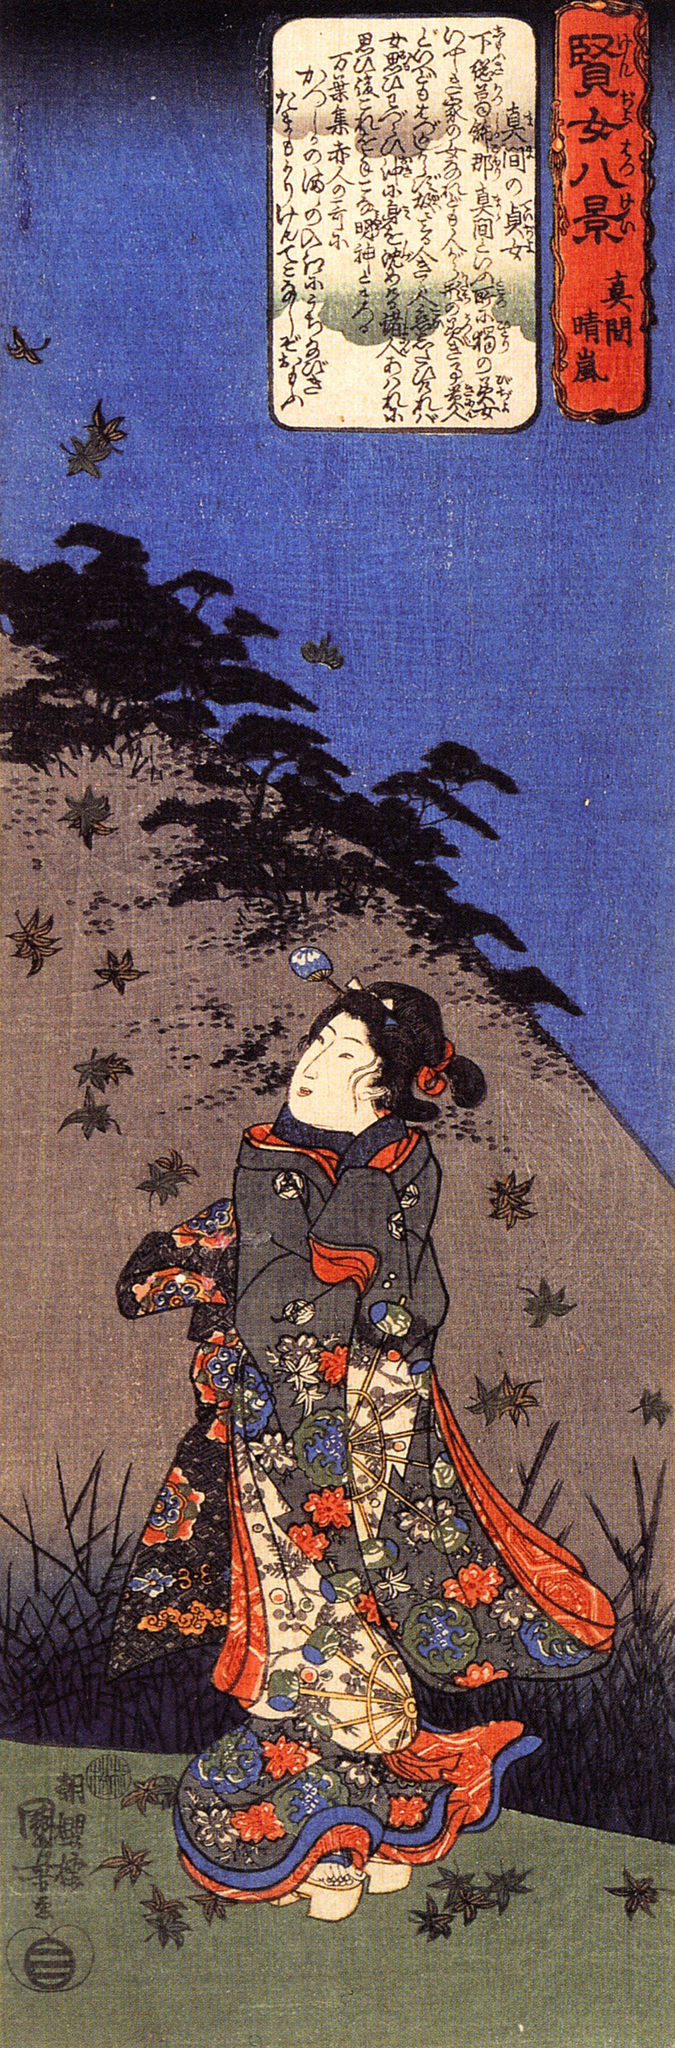Describe the historical context in which this artwork was created. This artwork is an example of ukiyo-e, a genre of Japanese woodblock prints that emerged during the Edo period (1603-1868). Ukiyo-e, which means 'pictures of the floating world,' often depicted scenes from everyday life, landscapes, and Kabuki theater actors. The Edo period was marked by a prolonged era of peace, economic growth, and flourishing arts and culture under the Tokugawa shogunate. Artists in this period often celebrated the transient beauty of life and day-to-day activities, which is evident in the detailed and vibrant depiction of the woman in the colorful kimono. The presence of the mountain and the birds in the background also reflects the Edo period's appreciation for nature and the delicate interplay between human life and the natural world. 